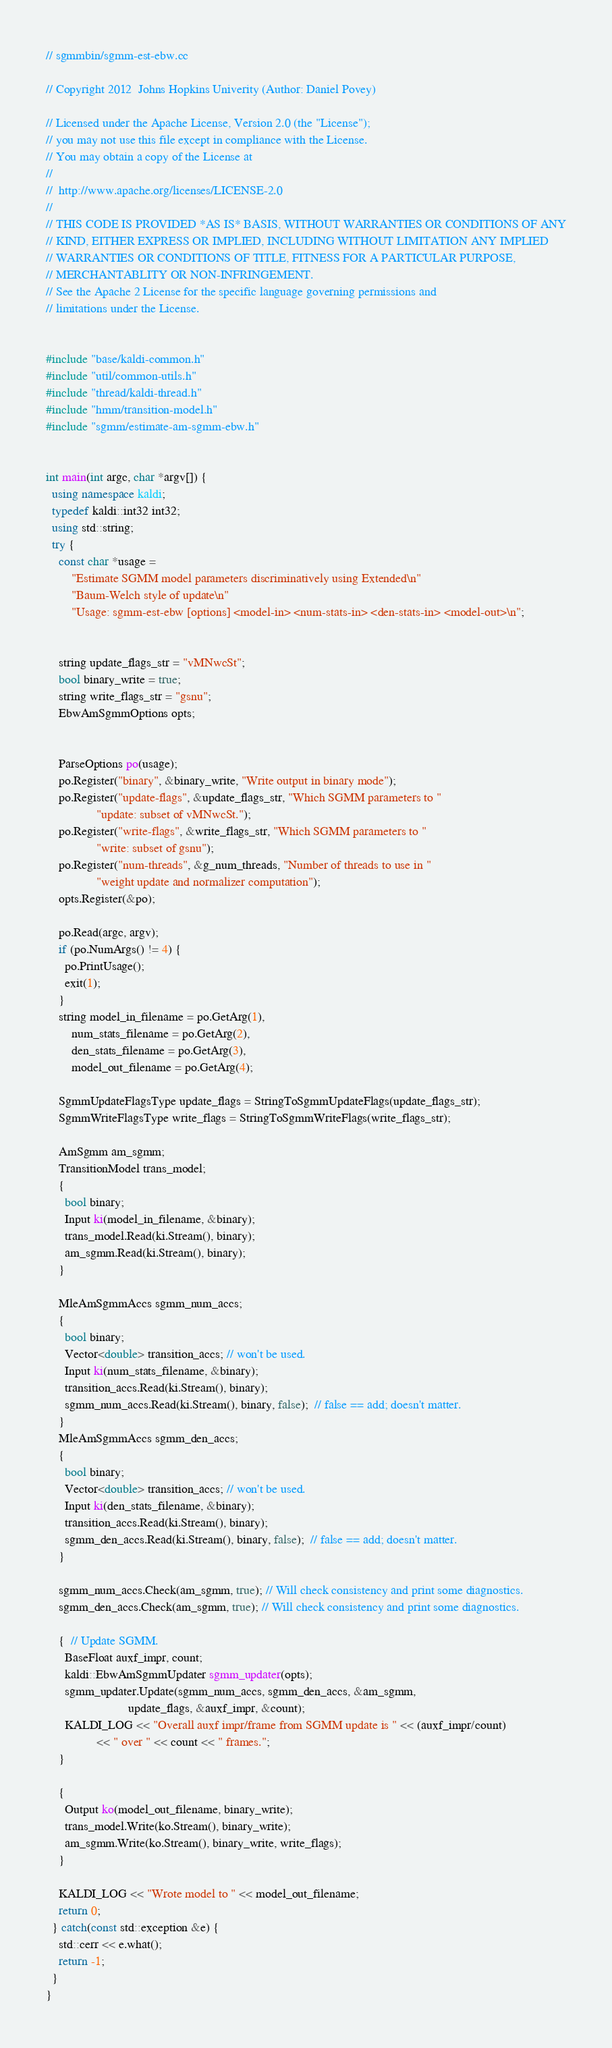<code> <loc_0><loc_0><loc_500><loc_500><_C++_>// sgmmbin/sgmm-est-ebw.cc

// Copyright 2012  Johns Hopkins Univerity (Author: Daniel Povey)

// Licensed under the Apache License, Version 2.0 (the "License");
// you may not use this file except in compliance with the License.
// You may obtain a copy of the License at
//
//  http://www.apache.org/licenses/LICENSE-2.0
//
// THIS CODE IS PROVIDED *AS IS* BASIS, WITHOUT WARRANTIES OR CONDITIONS OF ANY
// KIND, EITHER EXPRESS OR IMPLIED, INCLUDING WITHOUT LIMITATION ANY IMPLIED
// WARRANTIES OR CONDITIONS OF TITLE, FITNESS FOR A PARTICULAR PURPOSE,
// MERCHANTABLITY OR NON-INFRINGEMENT.
// See the Apache 2 License for the specific language governing permissions and
// limitations under the License.


#include "base/kaldi-common.h"
#include "util/common-utils.h"
#include "thread/kaldi-thread.h"
#include "hmm/transition-model.h"
#include "sgmm/estimate-am-sgmm-ebw.h"


int main(int argc, char *argv[]) {
  using namespace kaldi;
  typedef kaldi::int32 int32;
  using std::string;
  try {
    const char *usage =
        "Estimate SGMM model parameters discriminatively using Extended\n"
        "Baum-Welch style of update\n"
        "Usage: sgmm-est-ebw [options] <model-in> <num-stats-in> <den-stats-in> <model-out>\n";


    string update_flags_str = "vMNwcSt";
    bool binary_write = true;
    string write_flags_str = "gsnu";
    EbwAmSgmmOptions opts;

    
    ParseOptions po(usage);
    po.Register("binary", &binary_write, "Write output in binary mode");
    po.Register("update-flags", &update_flags_str, "Which SGMM parameters to "
                "update: subset of vMNwcSt.");
    po.Register("write-flags", &write_flags_str, "Which SGMM parameters to "
                "write: subset of gsnu");
    po.Register("num-threads", &g_num_threads, "Number of threads to use in "
                "weight update and normalizer computation");
    opts.Register(&po);

    po.Read(argc, argv);
    if (po.NumArgs() != 4) {
      po.PrintUsage();
      exit(1);
    }
    string model_in_filename = po.GetArg(1),
        num_stats_filename = po.GetArg(2),
        den_stats_filename = po.GetArg(3),
        model_out_filename = po.GetArg(4);
    
    SgmmUpdateFlagsType update_flags = StringToSgmmUpdateFlags(update_flags_str);
    SgmmWriteFlagsType write_flags = StringToSgmmWriteFlags(write_flags_str);

    AmSgmm am_sgmm;
    TransitionModel trans_model;
    {
      bool binary;
      Input ki(model_in_filename, &binary);
      trans_model.Read(ki.Stream(), binary);
      am_sgmm.Read(ki.Stream(), binary);
    }

    MleAmSgmmAccs sgmm_num_accs;
    {
      bool binary;
      Vector<double> transition_accs; // won't be used.
      Input ki(num_stats_filename, &binary);
      transition_accs.Read(ki.Stream(), binary);
      sgmm_num_accs.Read(ki.Stream(), binary, false);  // false == add; doesn't matter.
    }
    MleAmSgmmAccs sgmm_den_accs;
    {
      bool binary;
      Vector<double> transition_accs; // won't be used.
      Input ki(den_stats_filename, &binary);
      transition_accs.Read(ki.Stream(), binary);
      sgmm_den_accs.Read(ki.Stream(), binary, false);  // false == add; doesn't matter.
    }
    
    sgmm_num_accs.Check(am_sgmm, true); // Will check consistency and print some diagnostics.
    sgmm_den_accs.Check(am_sgmm, true); // Will check consistency and print some diagnostics.    

    {  // Update SGMM.
      BaseFloat auxf_impr, count;
      kaldi::EbwAmSgmmUpdater sgmm_updater(opts);
      sgmm_updater.Update(sgmm_num_accs, sgmm_den_accs, &am_sgmm,
                          update_flags, &auxf_impr, &count);
      KALDI_LOG << "Overall auxf impr/frame from SGMM update is " << (auxf_impr/count)
                << " over " << count << " frames.";
    }

    {
      Output ko(model_out_filename, binary_write);
      trans_model.Write(ko.Stream(), binary_write);
      am_sgmm.Write(ko.Stream(), binary_write, write_flags);
    }
    
    KALDI_LOG << "Wrote model to " << model_out_filename;
    return 0;
  } catch(const std::exception &e) {
    std::cerr << e.what();
    return -1;
  }
}
</code> 